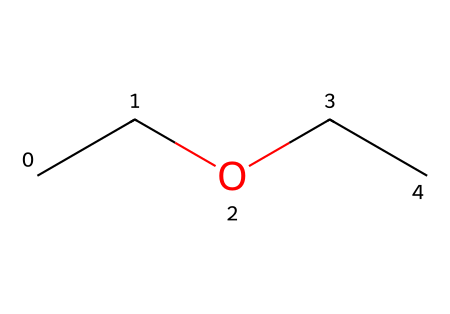What is the common name for the chemical represented by this SMILES? The SMILES "CCOCC" corresponds to diethyl ether, which is the common name for this chemical.
Answer: diethyl ether How many carbon atoms are present in the molecule? By analyzing the SMILES, there are four carbon atoms represented, as each "C" corresponds to a carbon atom in the structure.
Answer: 4 What type of functional group is present in diethyl ether? The presence of an oxygen atom connected to two aliphatic carbon chains indicates this is an ether functional group, characterized by an R-O-R' structure.
Answer: ether What is the total number of hydrogen atoms in diethyl ether? Each carbon generally forms four bonds, and based on the structure, the total count of hydrogen atoms can be computed from the arrangement (two for the terminal carbons and four for the two internal carbons), resulting in ten hydrogen atoms.
Answer: 10 Why is diethyl ether considered a flammable liquid? The presence of carbon and hydrogen in its molecular structure indicates that diethyl ether can easily evaporate and ignite, which is characteristic of flammable liquids; its low flash point also contributes to this property.
Answer: low flash point 